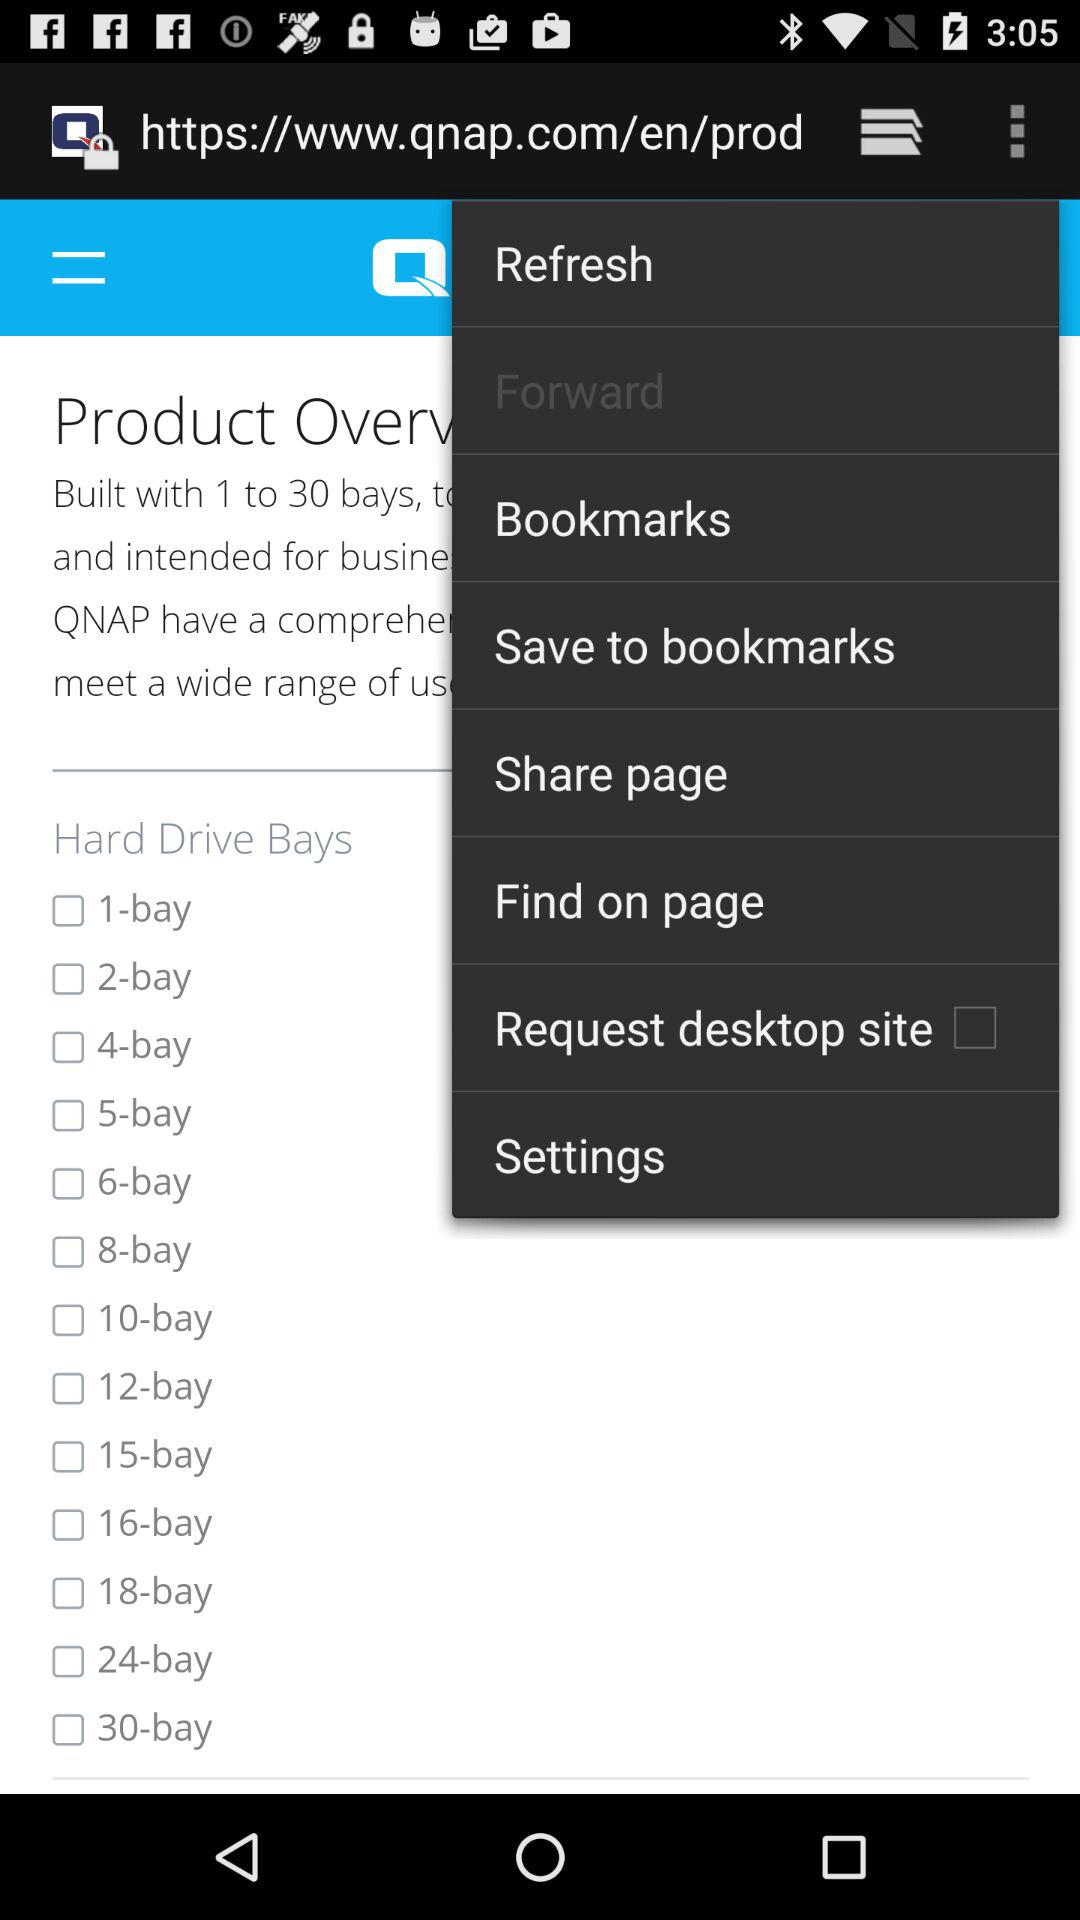Is "2-bay" selected or not? "2-bay" is not selected. 